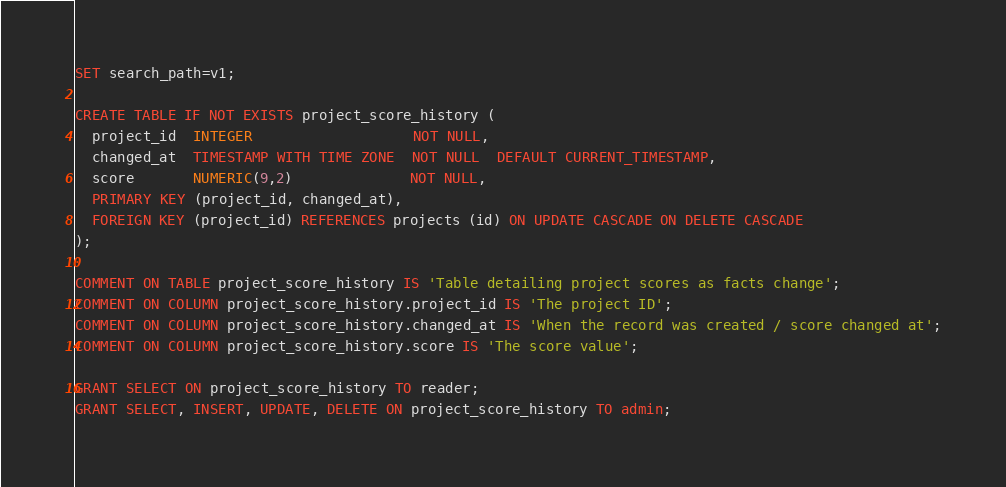<code> <loc_0><loc_0><loc_500><loc_500><_SQL_>SET search_path=v1;

CREATE TABLE IF NOT EXISTS project_score_history (
  project_id  INTEGER                   NOT NULL,
  changed_at  TIMESTAMP WITH TIME ZONE  NOT NULL  DEFAULT CURRENT_TIMESTAMP,
  score       NUMERIC(9,2)              NOT NULL,
  PRIMARY KEY (project_id, changed_at),
  FOREIGN KEY (project_id) REFERENCES projects (id) ON UPDATE CASCADE ON DELETE CASCADE
);

COMMENT ON TABLE project_score_history IS 'Table detailing project scores as facts change';
COMMENT ON COLUMN project_score_history.project_id IS 'The project ID';
COMMENT ON COLUMN project_score_history.changed_at IS 'When the record was created / score changed at';
COMMENT ON COLUMN project_score_history.score IS 'The score value';

GRANT SELECT ON project_score_history TO reader;
GRANT SELECT, INSERT, UPDATE, DELETE ON project_score_history TO admin;
</code> 